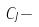<formula> <loc_0><loc_0><loc_500><loc_500>C _ { J } -</formula> 